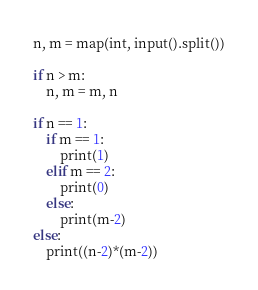Convert code to text. <code><loc_0><loc_0><loc_500><loc_500><_Python_>n, m = map(int, input().split())

if n > m:
    n, m = m, n

if n == 1:
    if m == 1:
        print(1)
    elif m == 2:
        print(0)
    else:
        print(m-2)
else:
    print((n-2)*(m-2))</code> 